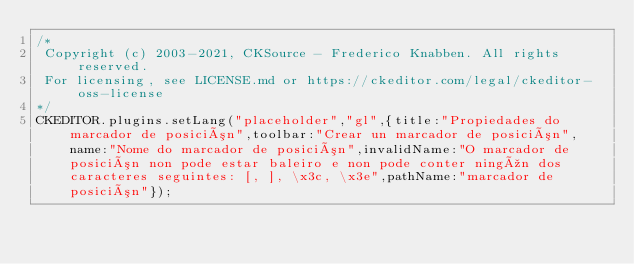<code> <loc_0><loc_0><loc_500><loc_500><_JavaScript_>/*
 Copyright (c) 2003-2021, CKSource - Frederico Knabben. All rights reserved.
 For licensing, see LICENSE.md or https://ckeditor.com/legal/ckeditor-oss-license
*/
CKEDITOR.plugins.setLang("placeholder","gl",{title:"Propiedades do marcador de posición",toolbar:"Crear un marcador de posición",name:"Nome do marcador de posición",invalidName:"O marcador de posición non pode estar baleiro e non pode conter ningún dos caracteres seguintes: [, ], \x3c, \x3e",pathName:"marcador de posición"});</code> 